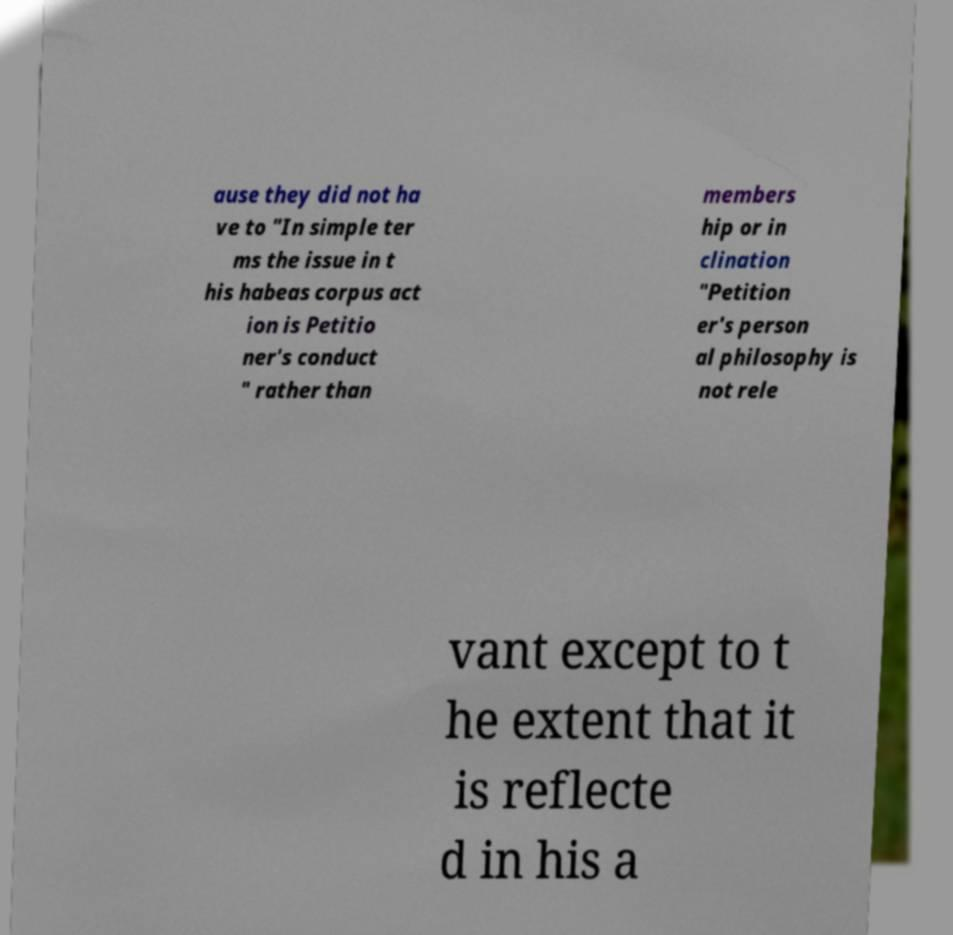Could you extract and type out the text from this image? ause they did not ha ve to "In simple ter ms the issue in t his habeas corpus act ion is Petitio ner's conduct " rather than members hip or in clination "Petition er's person al philosophy is not rele vant except to t he extent that it is reflecte d in his a 